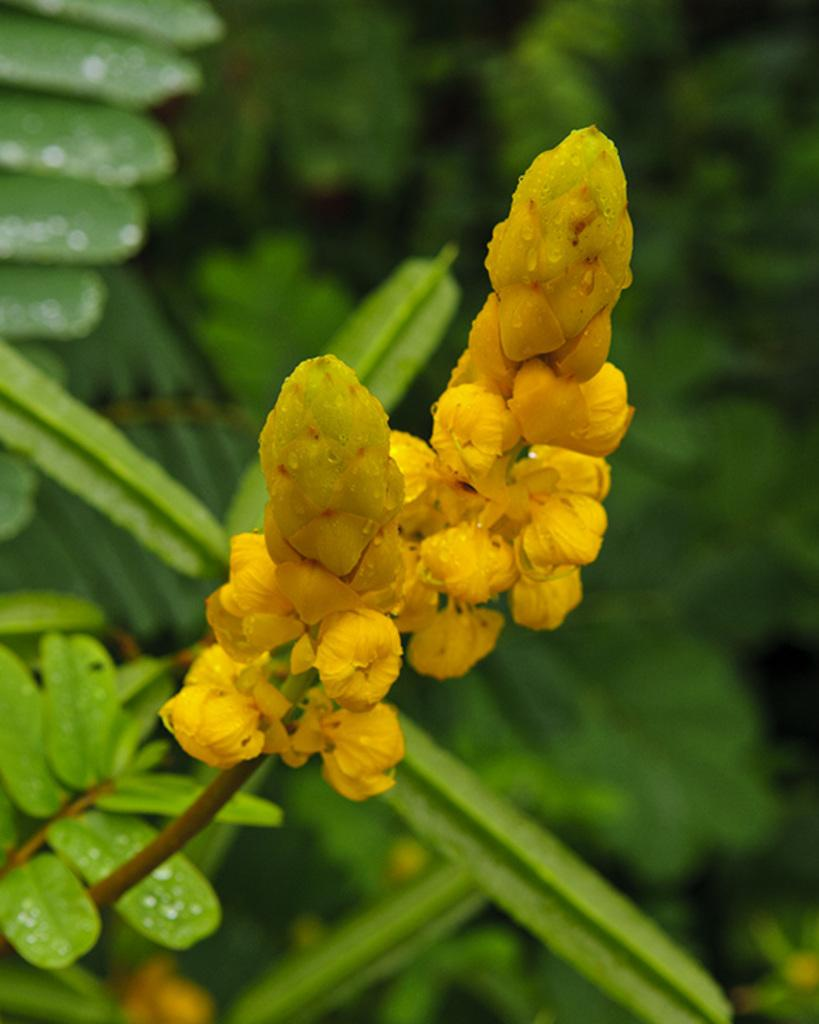What type of plant parts can be seen in the image? There are flower buds, stems, and leaves in the image. What is the overall setting of the image? The background of the image includes greenery. Can you see the moon in the image? No, the moon is not present in the image; it features flower buds, stems, leaves, and greenery in the background. 